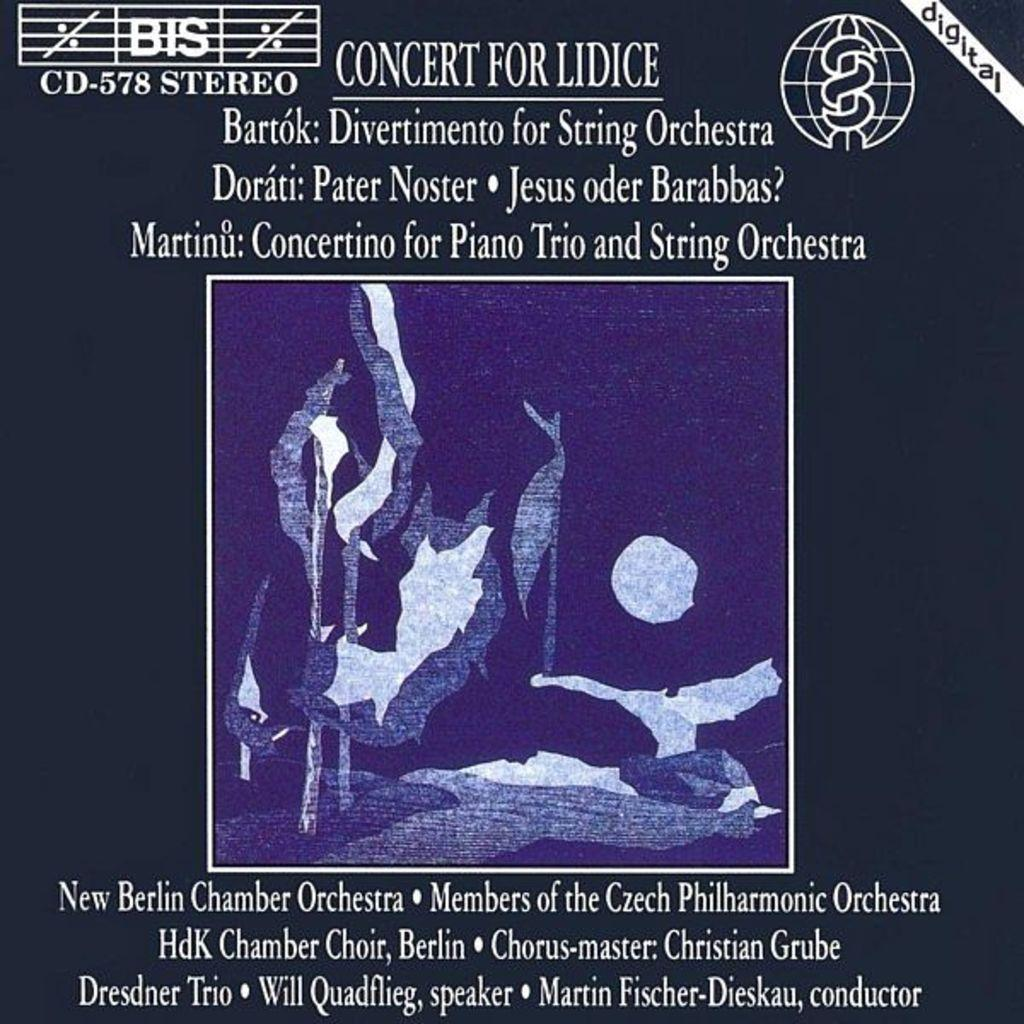Provide a one-sentence caption for the provided image. A blue advertisement for the Concert for Lidice. 